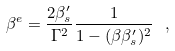Convert formula to latex. <formula><loc_0><loc_0><loc_500><loc_500>\beta ^ { e } = \frac { 2 \beta ^ { \prime } _ { s } } { \Gamma ^ { 2 } } \frac { 1 } { 1 - ( \beta \beta ^ { \prime } _ { s } ) ^ { 2 } } \ ,</formula> 